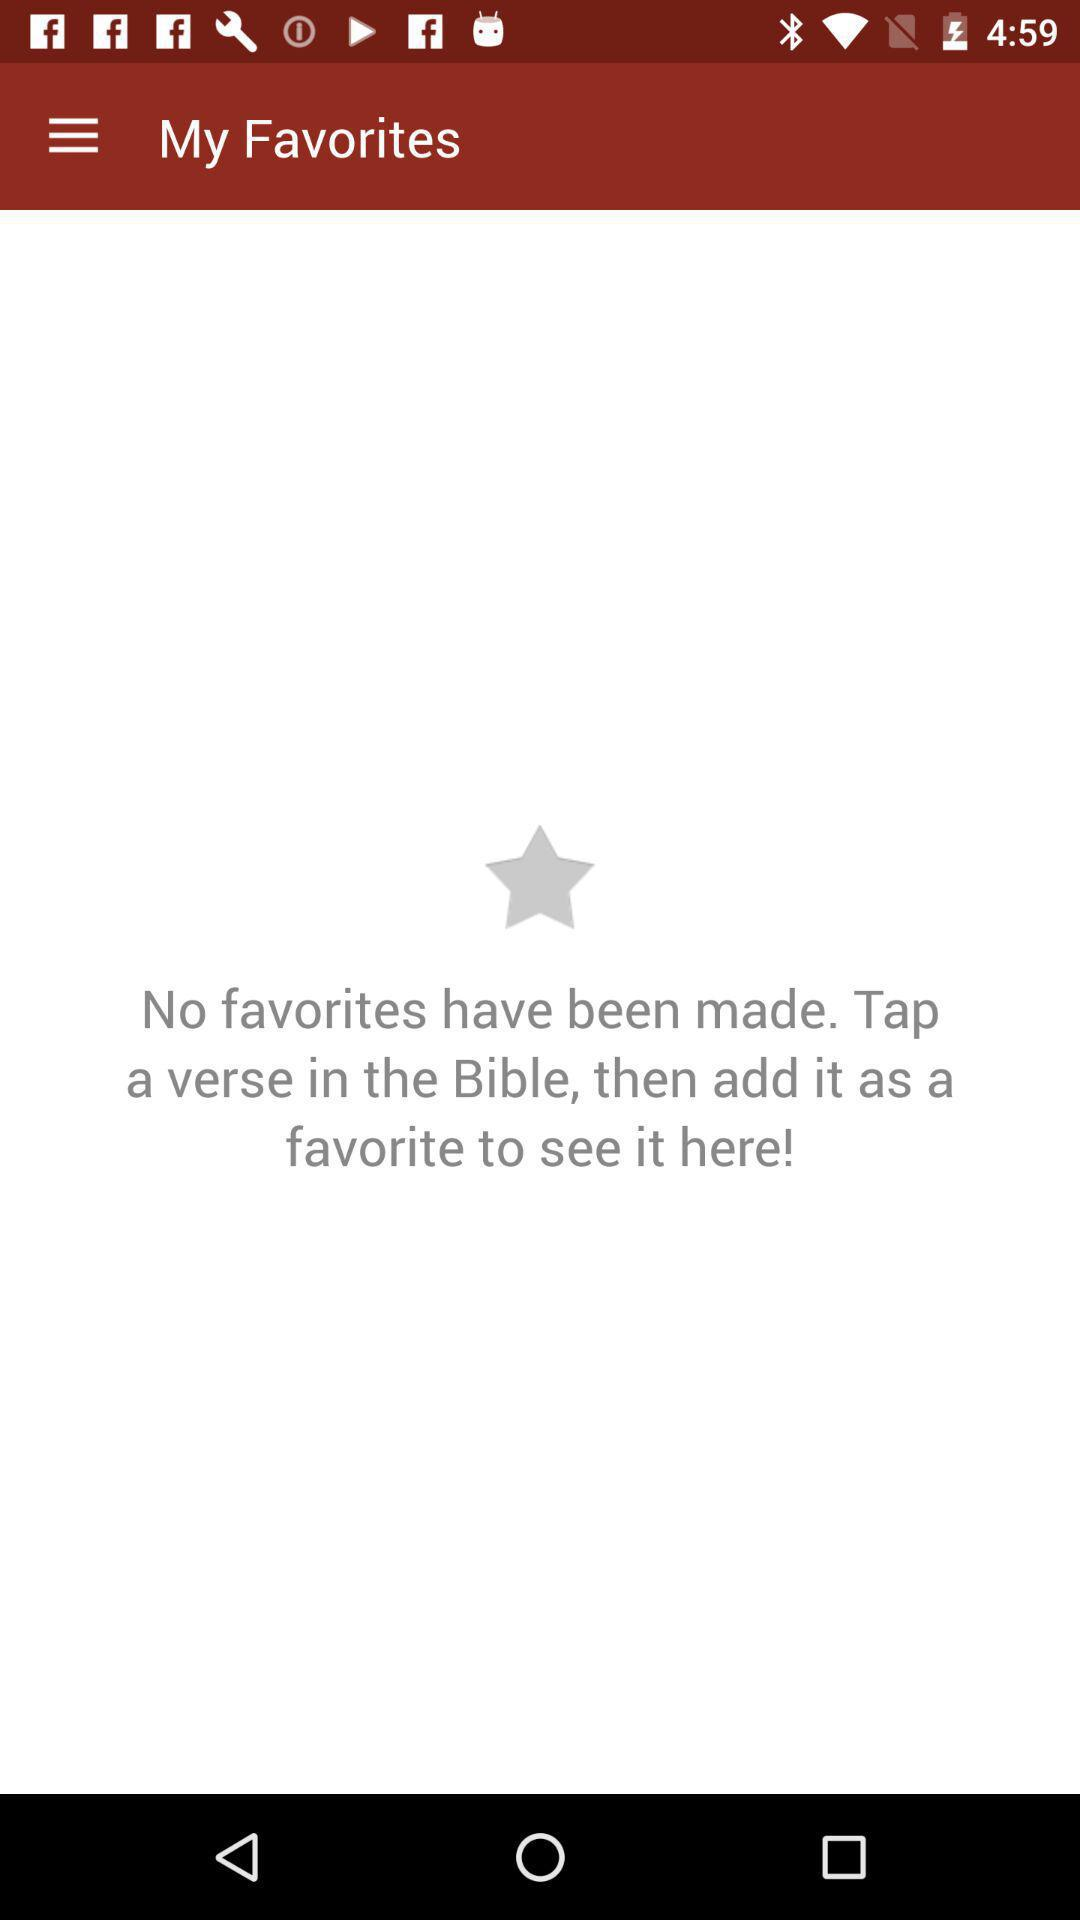How many favorites have been made?
Answer the question using a single word or phrase. 0 